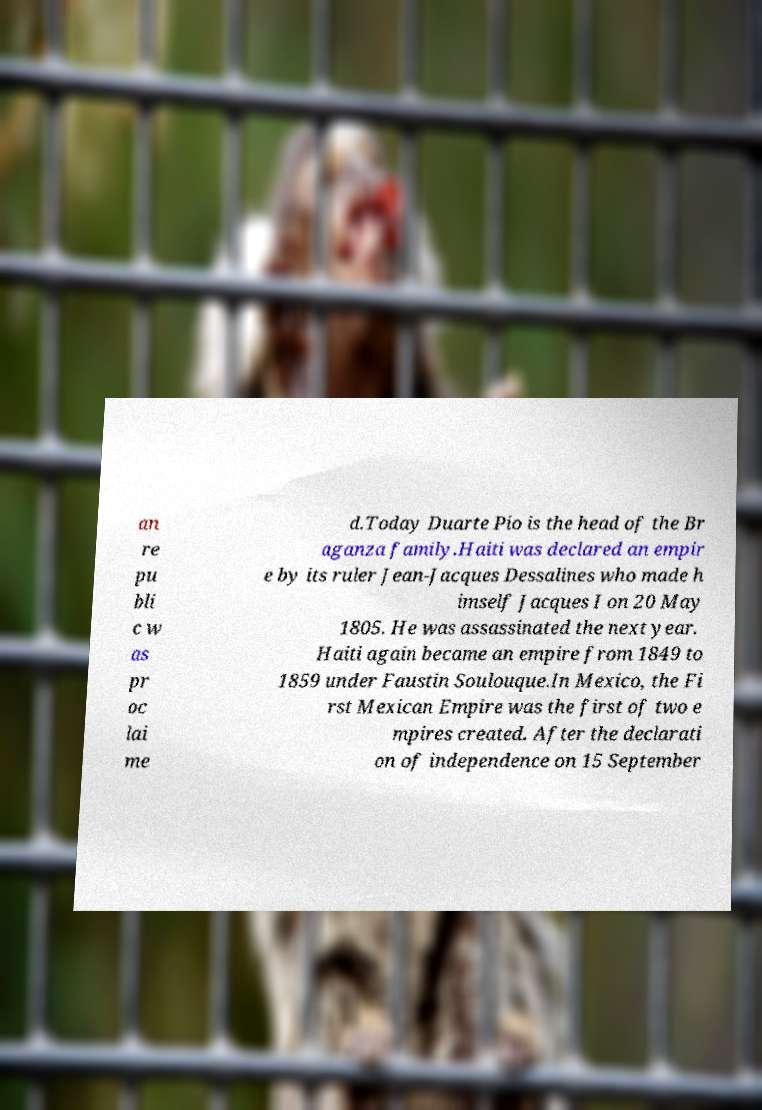Could you extract and type out the text from this image? an re pu bli c w as pr oc lai me d.Today Duarte Pio is the head of the Br aganza family.Haiti was declared an empir e by its ruler Jean-Jacques Dessalines who made h imself Jacques I on 20 May 1805. He was assassinated the next year. Haiti again became an empire from 1849 to 1859 under Faustin Soulouque.In Mexico, the Fi rst Mexican Empire was the first of two e mpires created. After the declarati on of independence on 15 September 